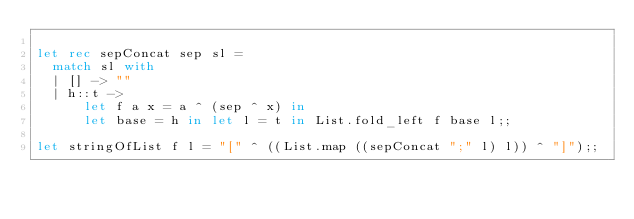Convert code to text. <code><loc_0><loc_0><loc_500><loc_500><_OCaml_>
let rec sepConcat sep sl =
  match sl with
  | [] -> ""
  | h::t ->
      let f a x = a ^ (sep ^ x) in
      let base = h in let l = t in List.fold_left f base l;;

let stringOfList f l = "[" ^ ((List.map ((sepConcat ";" l) l)) ^ "]");;
</code> 